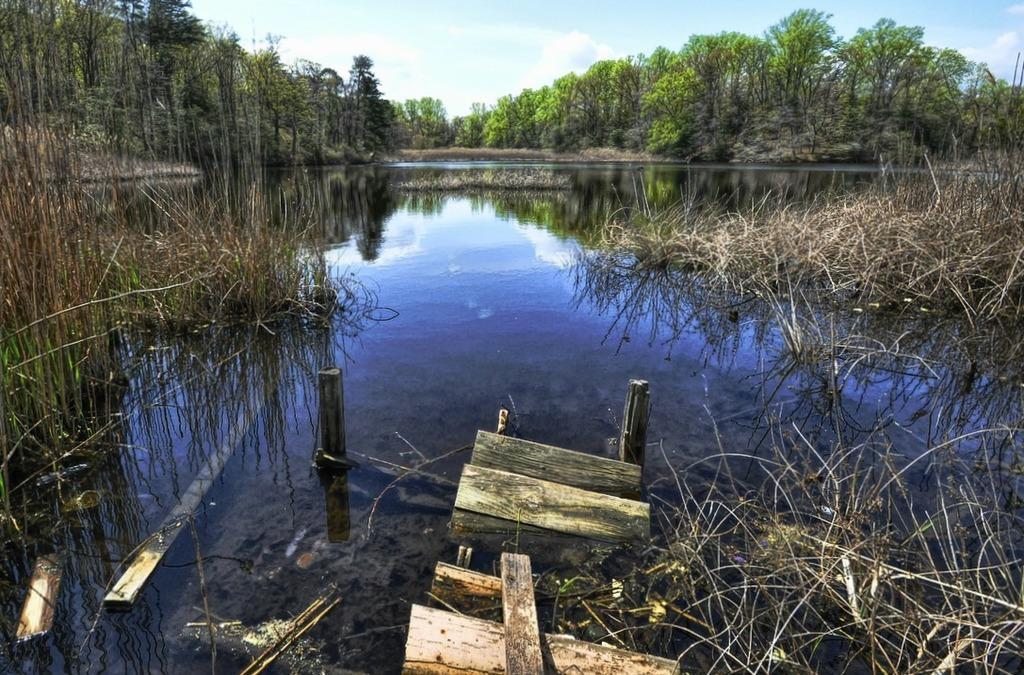How would you summarize this image in a sentence or two? In this image I can see few green trees, water, dry grass and few wooden objects and poles. The sky is in blue and white color. 